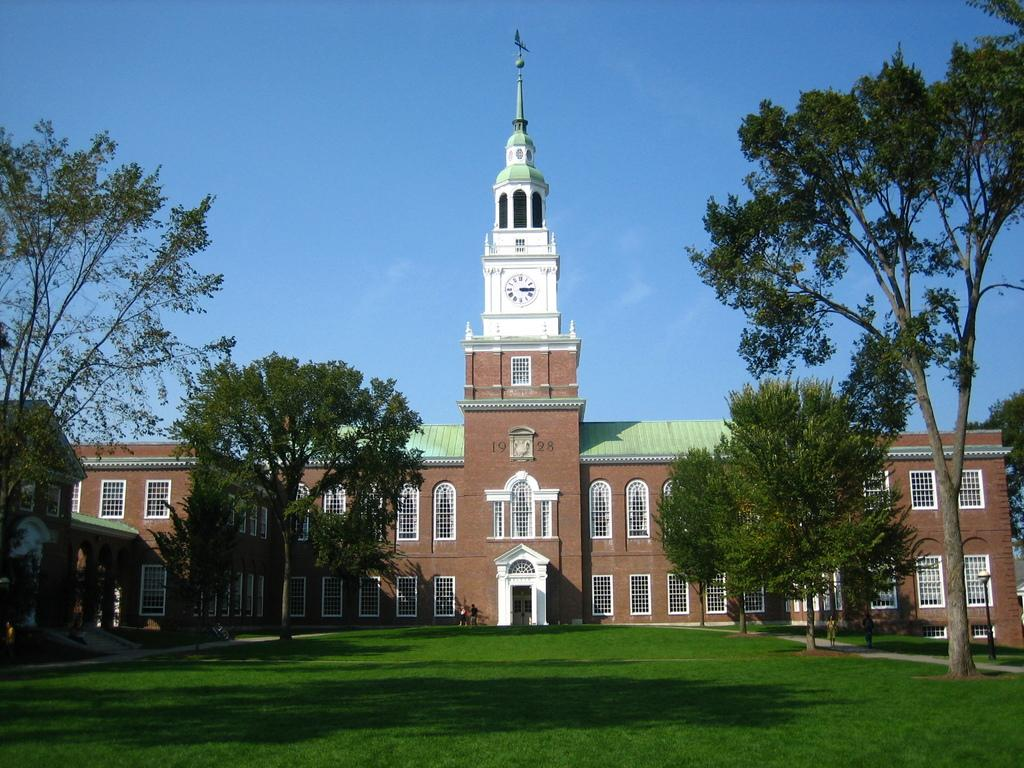What type of structure is present in the image? There is a building in the image. How many windows can be seen on the building? There are multiple windows on the building. What type of vegetation is visible in the image? There are trees in the image. What part of the natural environment is visible in the image? The sky is visible in the image. What time-telling device is present in the image? There is a clock in the image. What type of illumination is present in the image? There is a light in the image. What type of ground surface is visible in the image? Grass is visible in the image. What type of bone is visible in the image? There is no bone present in the image. What type of horn can be seen on the building in the image? There is no horn present on the building in the image. 